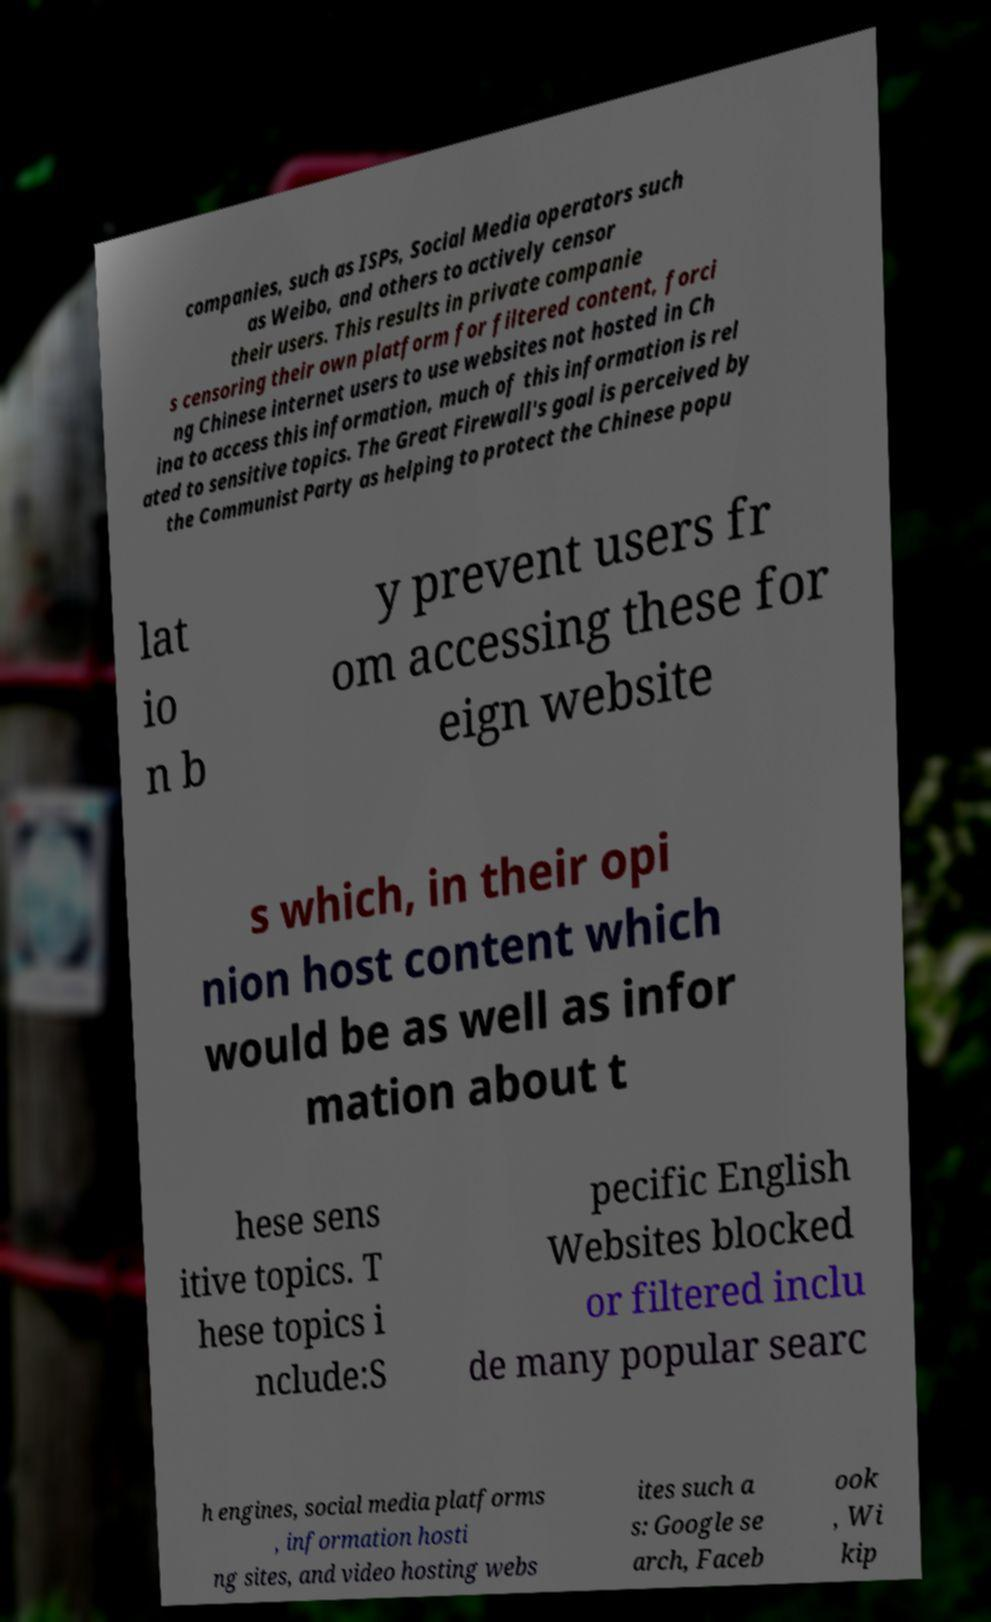Please read and relay the text visible in this image. What does it say? companies, such as ISPs, Social Media operators such as Weibo, and others to actively censor their users. This results in private companie s censoring their own platform for filtered content, forci ng Chinese internet users to use websites not hosted in Ch ina to access this information, much of this information is rel ated to sensitive topics. The Great Firewall's goal is perceived by the Communist Party as helping to protect the Chinese popu lat io n b y prevent users fr om accessing these for eign website s which, in their opi nion host content which would be as well as infor mation about t hese sens itive topics. T hese topics i nclude:S pecific English Websites blocked or filtered inclu de many popular searc h engines, social media platforms , information hosti ng sites, and video hosting webs ites such a s: Google se arch, Faceb ook , Wi kip 